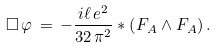Convert formula to latex. <formula><loc_0><loc_0><loc_500><loc_500>\square \, \varphi \, = \, - \frac { i \ell \, e ^ { 2 } } { 3 2 \, \pi ^ { 2 } } \ast \left ( F _ { A } \wedge F _ { A } \right ) .</formula> 